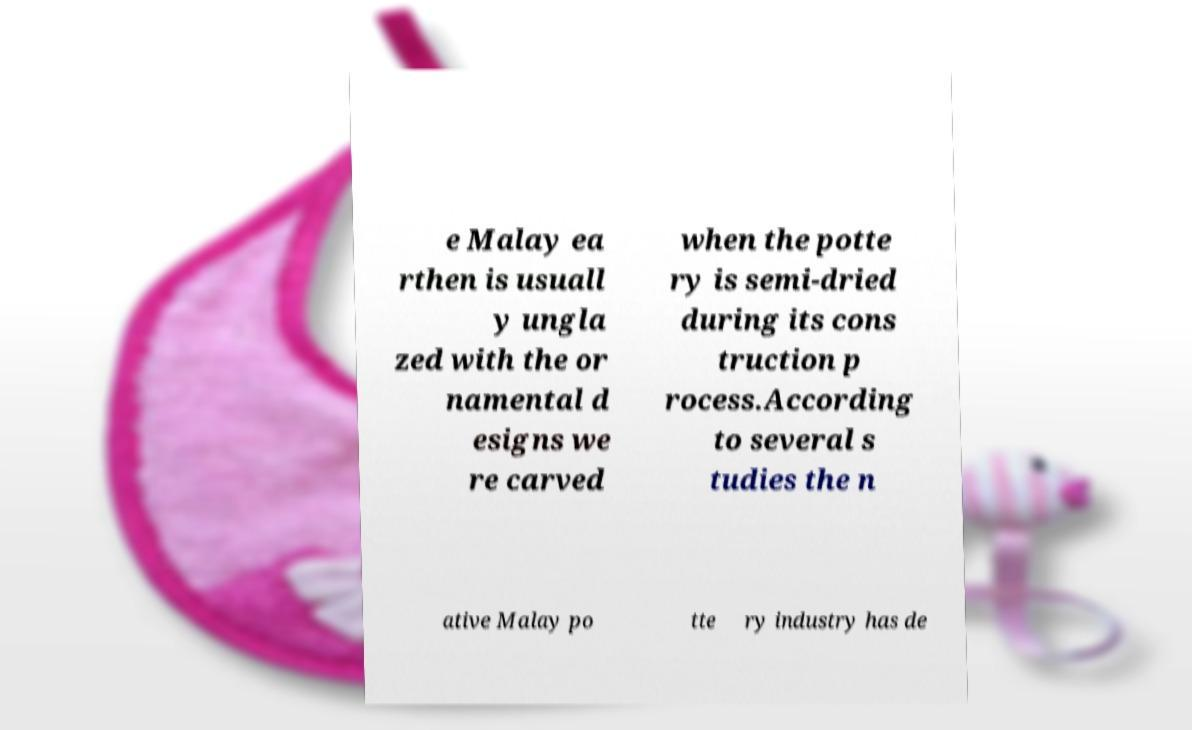I need the written content from this picture converted into text. Can you do that? e Malay ea rthen is usuall y ungla zed with the or namental d esigns we re carved when the potte ry is semi-dried during its cons truction p rocess.According to several s tudies the n ative Malay po tte ry industry has de 